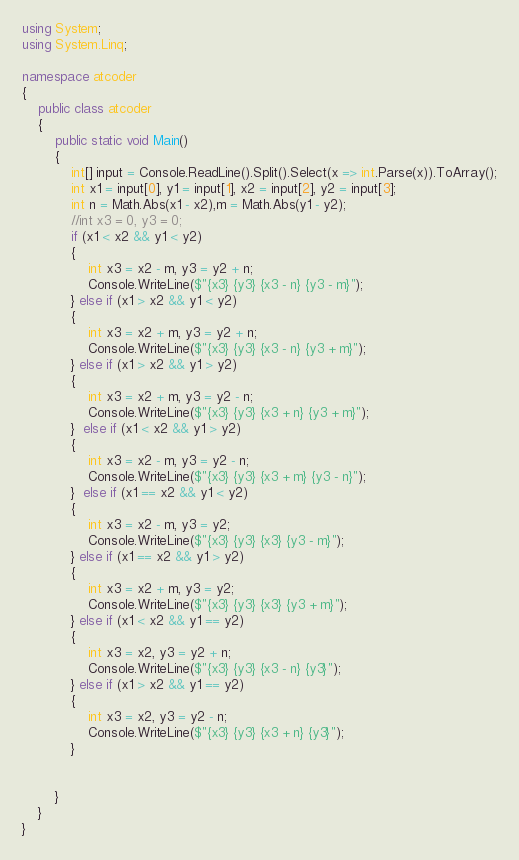Convert code to text. <code><loc_0><loc_0><loc_500><loc_500><_C#_>using System;
using System.Linq;

namespace atcoder
{
    public class atcoder
    {
        public static void Main()
        {
            int[] input = Console.ReadLine().Split().Select(x => int.Parse(x)).ToArray();
            int x1 = input[0], y1 = input[1], x2 = input[2], y2 = input[3];
            int n = Math.Abs(x1 - x2),m = Math.Abs(y1 - y2);
            //int x3 = 0, y3 = 0;
            if (x1 < x2 && y1 < y2) 
            {
                int x3 = x2 - m, y3 = y2 + n;
                Console.WriteLine($"{x3} {y3} {x3 - n} {y3 - m}");
            } else if (x1 > x2 && y1 < y2)
            {
                int x3 = x2 + m, y3 = y2 + n;
                Console.WriteLine($"{x3} {y3} {x3 - n} {y3 + m}");
            } else if (x1 > x2 && y1 > y2)
            {
                int x3 = x2 + m, y3 = y2 - n;
                Console.WriteLine($"{x3} {y3} {x3 + n} {y3 + m}");
            }  else if (x1 < x2 && y1 > y2)
            {
                int x3 = x2 - m, y3 = y2 - n;
                Console.WriteLine($"{x3} {y3} {x3 + m} {y3 - n}");
            }  else if (x1 == x2 && y1 < y2)
            {
                int x3 = x2 - m, y3 = y2;
                Console.WriteLine($"{x3} {y3} {x3} {y3 - m}");
            } else if (x1 == x2 && y1 > y2)
            {
                int x3 = x2 + m, y3 = y2;
                Console.WriteLine($"{x3} {y3} {x3} {y3 + m}");
            } else if (x1 < x2 && y1 == y2)
            {
                int x3 = x2, y3 = y2 + n;
                Console.WriteLine($"{x3} {y3} {x3 - n} {y3}");
            } else if (x1 > x2 && y1 == y2)
            {
                int x3 = x2, y3 = y2 - n;
                Console.WriteLine($"{x3} {y3} {x3 + n} {y3}");
            }


        }
    }
}
</code> 